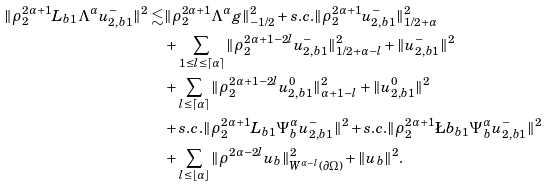Convert formula to latex. <formula><loc_0><loc_0><loc_500><loc_500>\| \rho _ { 2 } ^ { 2 \alpha + 1 } L _ { b 1 } \Lambda ^ { \alpha } u _ { 2 , b 1 } ^ { - } \| ^ { 2 } \lesssim & \| \rho _ { 2 } ^ { 2 \alpha + 1 } \Lambda ^ { \alpha } g \| _ { - 1 / 2 } ^ { 2 } + s . c . \| \rho _ { 2 } ^ { 2 \alpha + 1 } u _ { 2 , b 1 } ^ { - } \| _ { 1 / 2 + \alpha } ^ { 2 } \\ & + \sum _ { 1 \leq l \leq \lceil \alpha \rceil } \| \rho _ { 2 } ^ { 2 \alpha + 1 - 2 l } u _ { 2 , b 1 } ^ { - } \| _ { 1 / 2 + \alpha - l } ^ { 2 } + \| u _ { 2 , b 1 } ^ { - } \| ^ { 2 } \\ & + \sum _ { l \leq \lceil \alpha \rceil } \| \rho _ { 2 } ^ { 2 \alpha + 1 - 2 l } u _ { 2 , b 1 } ^ { 0 } \| _ { \alpha + 1 - l } ^ { 2 } + \| u _ { 2 , b 1 } ^ { 0 } \| ^ { 2 } \\ & + s . c . \| \rho _ { 2 } ^ { 2 \alpha + 1 } L _ { b 1 } \Psi _ { b } ^ { \alpha } u _ { 2 , b 1 } ^ { - } \| ^ { 2 } + s . c . \| \rho _ { 2 } ^ { 2 \alpha + 1 } \L b _ { b 1 } \Psi _ { b } ^ { \alpha } u _ { 2 , b 1 } ^ { - } \| ^ { 2 } \\ & + \sum _ { l \leq \lfloor \alpha \rfloor } \| \rho ^ { 2 \alpha - 2 l } u _ { b } \| _ { W ^ { \alpha - l } ( \partial \Omega ) } ^ { 2 } + \| u _ { b } \| ^ { 2 } .</formula> 